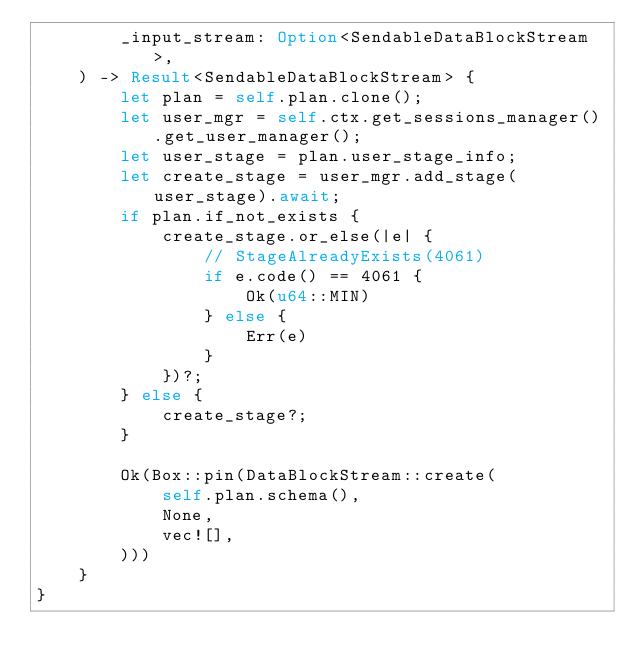<code> <loc_0><loc_0><loc_500><loc_500><_Rust_>        _input_stream: Option<SendableDataBlockStream>,
    ) -> Result<SendableDataBlockStream> {
        let plan = self.plan.clone();
        let user_mgr = self.ctx.get_sessions_manager().get_user_manager();
        let user_stage = plan.user_stage_info;
        let create_stage = user_mgr.add_stage(user_stage).await;
        if plan.if_not_exists {
            create_stage.or_else(|e| {
                // StageAlreadyExists(4061)
                if e.code() == 4061 {
                    Ok(u64::MIN)
                } else {
                    Err(e)
                }
            })?;
        } else {
            create_stage?;
        }

        Ok(Box::pin(DataBlockStream::create(
            self.plan.schema(),
            None,
            vec![],
        )))
    }
}
</code> 